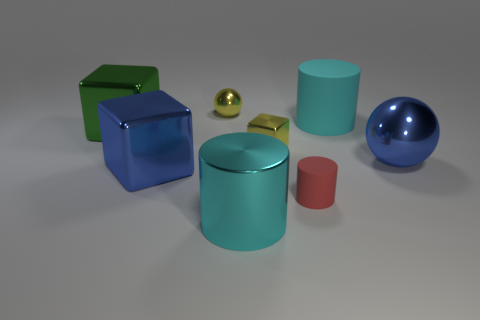Add 1 tiny brown rubber spheres. How many objects exist? 9 Subtract all brown spheres. Subtract all gray cubes. How many spheres are left? 2 Subtract all spheres. How many objects are left? 6 Subtract all large metallic cubes. Subtract all small gray matte objects. How many objects are left? 6 Add 8 matte cylinders. How many matte cylinders are left? 10 Add 6 blue metallic balls. How many blue metallic balls exist? 7 Subtract 0 cyan blocks. How many objects are left? 8 